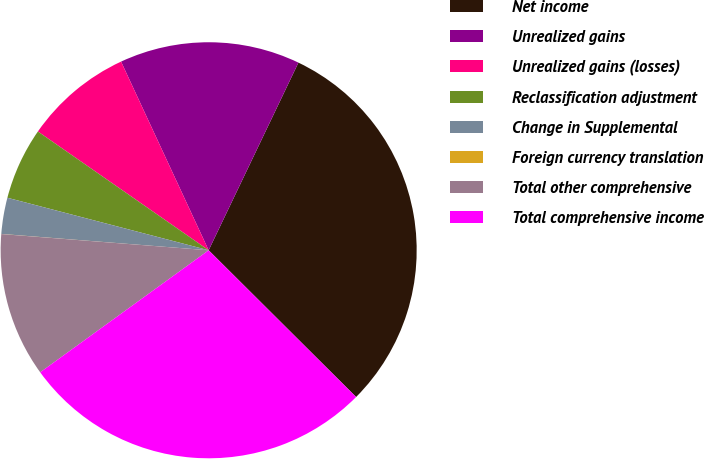<chart> <loc_0><loc_0><loc_500><loc_500><pie_chart><fcel>Net income<fcel>Unrealized gains<fcel>Unrealized gains (losses)<fcel>Reclassification adjustment<fcel>Change in Supplemental<fcel>Foreign currency translation<fcel>Total other comprehensive<fcel>Total comprehensive income<nl><fcel>30.36%<fcel>14.02%<fcel>8.41%<fcel>5.61%<fcel>2.81%<fcel>0.01%<fcel>11.22%<fcel>27.56%<nl></chart> 